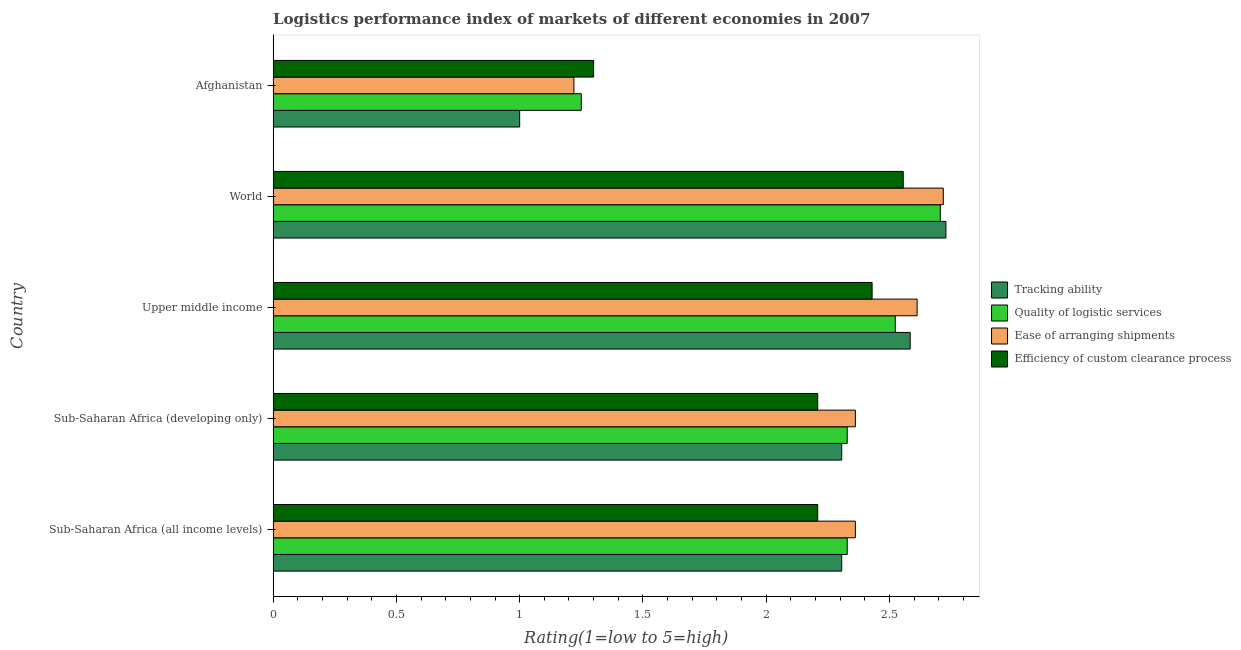How many groups of bars are there?
Provide a short and direct response. 5. Are the number of bars per tick equal to the number of legend labels?
Make the answer very short. Yes. How many bars are there on the 4th tick from the top?
Provide a succinct answer. 4. What is the label of the 4th group of bars from the top?
Offer a very short reply. Sub-Saharan Africa (developing only). In how many cases, is the number of bars for a given country not equal to the number of legend labels?
Give a very brief answer. 0. What is the lpi rating of efficiency of custom clearance process in Sub-Saharan Africa (developing only)?
Provide a short and direct response. 2.21. Across all countries, what is the maximum lpi rating of tracking ability?
Ensure brevity in your answer.  2.73. In which country was the lpi rating of tracking ability minimum?
Provide a short and direct response. Afghanistan. What is the total lpi rating of efficiency of custom clearance process in the graph?
Make the answer very short. 10.7. What is the difference between the lpi rating of quality of logistic services in Sub-Saharan Africa (all income levels) and that in Upper middle income?
Your answer should be compact. -0.2. What is the difference between the lpi rating of quality of logistic services in World and the lpi rating of ease of arranging shipments in Afghanistan?
Keep it short and to the point. 1.49. What is the average lpi rating of tracking ability per country?
Offer a very short reply. 2.19. What is the difference between the lpi rating of tracking ability and lpi rating of efficiency of custom clearance process in Sub-Saharan Africa (developing only)?
Offer a very short reply. 0.1. In how many countries, is the lpi rating of quality of logistic services greater than 0.2 ?
Your answer should be very brief. 5. What is the ratio of the lpi rating of ease of arranging shipments in Sub-Saharan Africa (all income levels) to that in World?
Make the answer very short. 0.87. Is the lpi rating of ease of arranging shipments in Sub-Saharan Africa (all income levels) less than that in World?
Your response must be concise. Yes. What is the difference between the highest and the second highest lpi rating of tracking ability?
Ensure brevity in your answer.  0.14. What is the difference between the highest and the lowest lpi rating of quality of logistic services?
Your answer should be very brief. 1.46. Is the sum of the lpi rating of efficiency of custom clearance process in Sub-Saharan Africa (all income levels) and Sub-Saharan Africa (developing only) greater than the maximum lpi rating of tracking ability across all countries?
Give a very brief answer. Yes. Is it the case that in every country, the sum of the lpi rating of efficiency of custom clearance process and lpi rating of tracking ability is greater than the sum of lpi rating of quality of logistic services and lpi rating of ease of arranging shipments?
Your answer should be very brief. No. What does the 2nd bar from the top in World represents?
Your answer should be compact. Ease of arranging shipments. What does the 3rd bar from the bottom in World represents?
Your answer should be very brief. Ease of arranging shipments. Are all the bars in the graph horizontal?
Your answer should be compact. Yes. Are the values on the major ticks of X-axis written in scientific E-notation?
Your answer should be very brief. No. Does the graph contain grids?
Ensure brevity in your answer.  No. Where does the legend appear in the graph?
Your answer should be compact. Center right. What is the title of the graph?
Keep it short and to the point. Logistics performance index of markets of different economies in 2007. What is the label or title of the X-axis?
Provide a short and direct response. Rating(1=low to 5=high). What is the Rating(1=low to 5=high) in Tracking ability in Sub-Saharan Africa (all income levels)?
Provide a short and direct response. 2.31. What is the Rating(1=low to 5=high) of Quality of logistic services in Sub-Saharan Africa (all income levels)?
Make the answer very short. 2.33. What is the Rating(1=low to 5=high) in Ease of arranging shipments in Sub-Saharan Africa (all income levels)?
Your answer should be compact. 2.36. What is the Rating(1=low to 5=high) of Efficiency of custom clearance process in Sub-Saharan Africa (all income levels)?
Make the answer very short. 2.21. What is the Rating(1=low to 5=high) of Tracking ability in Sub-Saharan Africa (developing only)?
Offer a terse response. 2.31. What is the Rating(1=low to 5=high) in Quality of logistic services in Sub-Saharan Africa (developing only)?
Offer a very short reply. 2.33. What is the Rating(1=low to 5=high) in Ease of arranging shipments in Sub-Saharan Africa (developing only)?
Give a very brief answer. 2.36. What is the Rating(1=low to 5=high) of Efficiency of custom clearance process in Sub-Saharan Africa (developing only)?
Provide a short and direct response. 2.21. What is the Rating(1=low to 5=high) of Tracking ability in Upper middle income?
Offer a terse response. 2.58. What is the Rating(1=low to 5=high) of Quality of logistic services in Upper middle income?
Offer a very short reply. 2.52. What is the Rating(1=low to 5=high) in Ease of arranging shipments in Upper middle income?
Offer a very short reply. 2.61. What is the Rating(1=low to 5=high) in Efficiency of custom clearance process in Upper middle income?
Your answer should be compact. 2.43. What is the Rating(1=low to 5=high) of Tracking ability in World?
Provide a succinct answer. 2.73. What is the Rating(1=low to 5=high) in Quality of logistic services in World?
Your answer should be very brief. 2.71. What is the Rating(1=low to 5=high) of Ease of arranging shipments in World?
Your answer should be compact. 2.72. What is the Rating(1=low to 5=high) in Efficiency of custom clearance process in World?
Offer a terse response. 2.56. What is the Rating(1=low to 5=high) in Ease of arranging shipments in Afghanistan?
Provide a succinct answer. 1.22. What is the Rating(1=low to 5=high) in Efficiency of custom clearance process in Afghanistan?
Ensure brevity in your answer.  1.3. Across all countries, what is the maximum Rating(1=low to 5=high) in Tracking ability?
Provide a short and direct response. 2.73. Across all countries, what is the maximum Rating(1=low to 5=high) of Quality of logistic services?
Your answer should be very brief. 2.71. Across all countries, what is the maximum Rating(1=low to 5=high) in Ease of arranging shipments?
Offer a terse response. 2.72. Across all countries, what is the maximum Rating(1=low to 5=high) in Efficiency of custom clearance process?
Ensure brevity in your answer.  2.56. Across all countries, what is the minimum Rating(1=low to 5=high) of Quality of logistic services?
Offer a terse response. 1.25. Across all countries, what is the minimum Rating(1=low to 5=high) in Ease of arranging shipments?
Offer a very short reply. 1.22. What is the total Rating(1=low to 5=high) in Tracking ability in the graph?
Give a very brief answer. 10.93. What is the total Rating(1=low to 5=high) of Quality of logistic services in the graph?
Your response must be concise. 11.14. What is the total Rating(1=low to 5=high) of Ease of arranging shipments in the graph?
Your answer should be very brief. 11.27. What is the total Rating(1=low to 5=high) in Efficiency of custom clearance process in the graph?
Provide a short and direct response. 10.7. What is the difference between the Rating(1=low to 5=high) in Quality of logistic services in Sub-Saharan Africa (all income levels) and that in Sub-Saharan Africa (developing only)?
Offer a terse response. 0. What is the difference between the Rating(1=low to 5=high) in Ease of arranging shipments in Sub-Saharan Africa (all income levels) and that in Sub-Saharan Africa (developing only)?
Your answer should be very brief. 0. What is the difference between the Rating(1=low to 5=high) of Efficiency of custom clearance process in Sub-Saharan Africa (all income levels) and that in Sub-Saharan Africa (developing only)?
Make the answer very short. 0. What is the difference between the Rating(1=low to 5=high) of Tracking ability in Sub-Saharan Africa (all income levels) and that in Upper middle income?
Your answer should be compact. -0.28. What is the difference between the Rating(1=low to 5=high) of Quality of logistic services in Sub-Saharan Africa (all income levels) and that in Upper middle income?
Your response must be concise. -0.2. What is the difference between the Rating(1=low to 5=high) of Ease of arranging shipments in Sub-Saharan Africa (all income levels) and that in Upper middle income?
Your answer should be very brief. -0.25. What is the difference between the Rating(1=low to 5=high) of Efficiency of custom clearance process in Sub-Saharan Africa (all income levels) and that in Upper middle income?
Provide a short and direct response. -0.22. What is the difference between the Rating(1=low to 5=high) of Tracking ability in Sub-Saharan Africa (all income levels) and that in World?
Your answer should be compact. -0.42. What is the difference between the Rating(1=low to 5=high) in Quality of logistic services in Sub-Saharan Africa (all income levels) and that in World?
Provide a succinct answer. -0.38. What is the difference between the Rating(1=low to 5=high) of Ease of arranging shipments in Sub-Saharan Africa (all income levels) and that in World?
Offer a very short reply. -0.36. What is the difference between the Rating(1=low to 5=high) of Efficiency of custom clearance process in Sub-Saharan Africa (all income levels) and that in World?
Your response must be concise. -0.35. What is the difference between the Rating(1=low to 5=high) of Tracking ability in Sub-Saharan Africa (all income levels) and that in Afghanistan?
Provide a succinct answer. 1.31. What is the difference between the Rating(1=low to 5=high) in Quality of logistic services in Sub-Saharan Africa (all income levels) and that in Afghanistan?
Provide a succinct answer. 1.08. What is the difference between the Rating(1=low to 5=high) of Ease of arranging shipments in Sub-Saharan Africa (all income levels) and that in Afghanistan?
Keep it short and to the point. 1.14. What is the difference between the Rating(1=low to 5=high) of Efficiency of custom clearance process in Sub-Saharan Africa (all income levels) and that in Afghanistan?
Offer a very short reply. 0.91. What is the difference between the Rating(1=low to 5=high) of Tracking ability in Sub-Saharan Africa (developing only) and that in Upper middle income?
Give a very brief answer. -0.28. What is the difference between the Rating(1=low to 5=high) in Quality of logistic services in Sub-Saharan Africa (developing only) and that in Upper middle income?
Make the answer very short. -0.2. What is the difference between the Rating(1=low to 5=high) of Ease of arranging shipments in Sub-Saharan Africa (developing only) and that in Upper middle income?
Your response must be concise. -0.25. What is the difference between the Rating(1=low to 5=high) in Efficiency of custom clearance process in Sub-Saharan Africa (developing only) and that in Upper middle income?
Make the answer very short. -0.22. What is the difference between the Rating(1=low to 5=high) of Tracking ability in Sub-Saharan Africa (developing only) and that in World?
Your answer should be compact. -0.42. What is the difference between the Rating(1=low to 5=high) in Quality of logistic services in Sub-Saharan Africa (developing only) and that in World?
Your response must be concise. -0.38. What is the difference between the Rating(1=low to 5=high) of Ease of arranging shipments in Sub-Saharan Africa (developing only) and that in World?
Offer a very short reply. -0.36. What is the difference between the Rating(1=low to 5=high) of Efficiency of custom clearance process in Sub-Saharan Africa (developing only) and that in World?
Your response must be concise. -0.35. What is the difference between the Rating(1=low to 5=high) of Tracking ability in Sub-Saharan Africa (developing only) and that in Afghanistan?
Your response must be concise. 1.31. What is the difference between the Rating(1=low to 5=high) of Quality of logistic services in Sub-Saharan Africa (developing only) and that in Afghanistan?
Your response must be concise. 1.08. What is the difference between the Rating(1=low to 5=high) of Ease of arranging shipments in Sub-Saharan Africa (developing only) and that in Afghanistan?
Your answer should be very brief. 1.14. What is the difference between the Rating(1=low to 5=high) in Efficiency of custom clearance process in Sub-Saharan Africa (developing only) and that in Afghanistan?
Keep it short and to the point. 0.91. What is the difference between the Rating(1=low to 5=high) in Tracking ability in Upper middle income and that in World?
Provide a succinct answer. -0.14. What is the difference between the Rating(1=low to 5=high) of Quality of logistic services in Upper middle income and that in World?
Your answer should be compact. -0.18. What is the difference between the Rating(1=low to 5=high) of Ease of arranging shipments in Upper middle income and that in World?
Your response must be concise. -0.11. What is the difference between the Rating(1=low to 5=high) of Efficiency of custom clearance process in Upper middle income and that in World?
Offer a very short reply. -0.13. What is the difference between the Rating(1=low to 5=high) of Tracking ability in Upper middle income and that in Afghanistan?
Provide a succinct answer. 1.58. What is the difference between the Rating(1=low to 5=high) of Quality of logistic services in Upper middle income and that in Afghanistan?
Your answer should be very brief. 1.27. What is the difference between the Rating(1=low to 5=high) of Ease of arranging shipments in Upper middle income and that in Afghanistan?
Your answer should be compact. 1.39. What is the difference between the Rating(1=low to 5=high) of Efficiency of custom clearance process in Upper middle income and that in Afghanistan?
Provide a short and direct response. 1.13. What is the difference between the Rating(1=low to 5=high) of Tracking ability in World and that in Afghanistan?
Provide a short and direct response. 1.73. What is the difference between the Rating(1=low to 5=high) of Quality of logistic services in World and that in Afghanistan?
Your answer should be compact. 1.46. What is the difference between the Rating(1=low to 5=high) in Ease of arranging shipments in World and that in Afghanistan?
Keep it short and to the point. 1.5. What is the difference between the Rating(1=low to 5=high) of Efficiency of custom clearance process in World and that in Afghanistan?
Give a very brief answer. 1.26. What is the difference between the Rating(1=low to 5=high) of Tracking ability in Sub-Saharan Africa (all income levels) and the Rating(1=low to 5=high) of Quality of logistic services in Sub-Saharan Africa (developing only)?
Provide a succinct answer. -0.02. What is the difference between the Rating(1=low to 5=high) in Tracking ability in Sub-Saharan Africa (all income levels) and the Rating(1=low to 5=high) in Ease of arranging shipments in Sub-Saharan Africa (developing only)?
Ensure brevity in your answer.  -0.06. What is the difference between the Rating(1=low to 5=high) of Tracking ability in Sub-Saharan Africa (all income levels) and the Rating(1=low to 5=high) of Efficiency of custom clearance process in Sub-Saharan Africa (developing only)?
Ensure brevity in your answer.  0.1. What is the difference between the Rating(1=low to 5=high) in Quality of logistic services in Sub-Saharan Africa (all income levels) and the Rating(1=low to 5=high) in Ease of arranging shipments in Sub-Saharan Africa (developing only)?
Your response must be concise. -0.03. What is the difference between the Rating(1=low to 5=high) in Quality of logistic services in Sub-Saharan Africa (all income levels) and the Rating(1=low to 5=high) in Efficiency of custom clearance process in Sub-Saharan Africa (developing only)?
Your answer should be compact. 0.12. What is the difference between the Rating(1=low to 5=high) of Ease of arranging shipments in Sub-Saharan Africa (all income levels) and the Rating(1=low to 5=high) of Efficiency of custom clearance process in Sub-Saharan Africa (developing only)?
Provide a short and direct response. 0.15. What is the difference between the Rating(1=low to 5=high) of Tracking ability in Sub-Saharan Africa (all income levels) and the Rating(1=low to 5=high) of Quality of logistic services in Upper middle income?
Your answer should be very brief. -0.22. What is the difference between the Rating(1=low to 5=high) of Tracking ability in Sub-Saharan Africa (all income levels) and the Rating(1=low to 5=high) of Ease of arranging shipments in Upper middle income?
Offer a terse response. -0.31. What is the difference between the Rating(1=low to 5=high) in Tracking ability in Sub-Saharan Africa (all income levels) and the Rating(1=low to 5=high) in Efficiency of custom clearance process in Upper middle income?
Offer a very short reply. -0.12. What is the difference between the Rating(1=low to 5=high) of Quality of logistic services in Sub-Saharan Africa (all income levels) and the Rating(1=low to 5=high) of Ease of arranging shipments in Upper middle income?
Your response must be concise. -0.28. What is the difference between the Rating(1=low to 5=high) in Quality of logistic services in Sub-Saharan Africa (all income levels) and the Rating(1=low to 5=high) in Efficiency of custom clearance process in Upper middle income?
Your answer should be very brief. -0.1. What is the difference between the Rating(1=low to 5=high) in Ease of arranging shipments in Sub-Saharan Africa (all income levels) and the Rating(1=low to 5=high) in Efficiency of custom clearance process in Upper middle income?
Your answer should be very brief. -0.07. What is the difference between the Rating(1=low to 5=high) of Tracking ability in Sub-Saharan Africa (all income levels) and the Rating(1=low to 5=high) of Quality of logistic services in World?
Your answer should be compact. -0.4. What is the difference between the Rating(1=low to 5=high) in Tracking ability in Sub-Saharan Africa (all income levels) and the Rating(1=low to 5=high) in Ease of arranging shipments in World?
Give a very brief answer. -0.41. What is the difference between the Rating(1=low to 5=high) of Tracking ability in Sub-Saharan Africa (all income levels) and the Rating(1=low to 5=high) of Efficiency of custom clearance process in World?
Provide a short and direct response. -0.25. What is the difference between the Rating(1=low to 5=high) of Quality of logistic services in Sub-Saharan Africa (all income levels) and the Rating(1=low to 5=high) of Ease of arranging shipments in World?
Provide a short and direct response. -0.39. What is the difference between the Rating(1=low to 5=high) of Quality of logistic services in Sub-Saharan Africa (all income levels) and the Rating(1=low to 5=high) of Efficiency of custom clearance process in World?
Ensure brevity in your answer.  -0.23. What is the difference between the Rating(1=low to 5=high) of Ease of arranging shipments in Sub-Saharan Africa (all income levels) and the Rating(1=low to 5=high) of Efficiency of custom clearance process in World?
Provide a succinct answer. -0.19. What is the difference between the Rating(1=low to 5=high) in Tracking ability in Sub-Saharan Africa (all income levels) and the Rating(1=low to 5=high) in Quality of logistic services in Afghanistan?
Offer a terse response. 1.06. What is the difference between the Rating(1=low to 5=high) in Tracking ability in Sub-Saharan Africa (all income levels) and the Rating(1=low to 5=high) in Ease of arranging shipments in Afghanistan?
Keep it short and to the point. 1.09. What is the difference between the Rating(1=low to 5=high) of Tracking ability in Sub-Saharan Africa (all income levels) and the Rating(1=low to 5=high) of Efficiency of custom clearance process in Afghanistan?
Your answer should be very brief. 1.01. What is the difference between the Rating(1=low to 5=high) of Quality of logistic services in Sub-Saharan Africa (all income levels) and the Rating(1=low to 5=high) of Ease of arranging shipments in Afghanistan?
Your answer should be very brief. 1.11. What is the difference between the Rating(1=low to 5=high) of Quality of logistic services in Sub-Saharan Africa (all income levels) and the Rating(1=low to 5=high) of Efficiency of custom clearance process in Afghanistan?
Make the answer very short. 1.03. What is the difference between the Rating(1=low to 5=high) of Ease of arranging shipments in Sub-Saharan Africa (all income levels) and the Rating(1=low to 5=high) of Efficiency of custom clearance process in Afghanistan?
Your response must be concise. 1.06. What is the difference between the Rating(1=low to 5=high) in Tracking ability in Sub-Saharan Africa (developing only) and the Rating(1=low to 5=high) in Quality of logistic services in Upper middle income?
Give a very brief answer. -0.22. What is the difference between the Rating(1=low to 5=high) of Tracking ability in Sub-Saharan Africa (developing only) and the Rating(1=low to 5=high) of Ease of arranging shipments in Upper middle income?
Your answer should be compact. -0.31. What is the difference between the Rating(1=low to 5=high) of Tracking ability in Sub-Saharan Africa (developing only) and the Rating(1=low to 5=high) of Efficiency of custom clearance process in Upper middle income?
Your answer should be compact. -0.12. What is the difference between the Rating(1=low to 5=high) of Quality of logistic services in Sub-Saharan Africa (developing only) and the Rating(1=low to 5=high) of Ease of arranging shipments in Upper middle income?
Give a very brief answer. -0.28. What is the difference between the Rating(1=low to 5=high) of Quality of logistic services in Sub-Saharan Africa (developing only) and the Rating(1=low to 5=high) of Efficiency of custom clearance process in Upper middle income?
Give a very brief answer. -0.1. What is the difference between the Rating(1=low to 5=high) of Ease of arranging shipments in Sub-Saharan Africa (developing only) and the Rating(1=low to 5=high) of Efficiency of custom clearance process in Upper middle income?
Provide a short and direct response. -0.07. What is the difference between the Rating(1=low to 5=high) of Tracking ability in Sub-Saharan Africa (developing only) and the Rating(1=low to 5=high) of Quality of logistic services in World?
Offer a terse response. -0.4. What is the difference between the Rating(1=low to 5=high) in Tracking ability in Sub-Saharan Africa (developing only) and the Rating(1=low to 5=high) in Ease of arranging shipments in World?
Provide a succinct answer. -0.41. What is the difference between the Rating(1=low to 5=high) of Tracking ability in Sub-Saharan Africa (developing only) and the Rating(1=low to 5=high) of Efficiency of custom clearance process in World?
Give a very brief answer. -0.25. What is the difference between the Rating(1=low to 5=high) of Quality of logistic services in Sub-Saharan Africa (developing only) and the Rating(1=low to 5=high) of Ease of arranging shipments in World?
Your response must be concise. -0.39. What is the difference between the Rating(1=low to 5=high) of Quality of logistic services in Sub-Saharan Africa (developing only) and the Rating(1=low to 5=high) of Efficiency of custom clearance process in World?
Your response must be concise. -0.23. What is the difference between the Rating(1=low to 5=high) in Ease of arranging shipments in Sub-Saharan Africa (developing only) and the Rating(1=low to 5=high) in Efficiency of custom clearance process in World?
Make the answer very short. -0.19. What is the difference between the Rating(1=low to 5=high) in Tracking ability in Sub-Saharan Africa (developing only) and the Rating(1=low to 5=high) in Quality of logistic services in Afghanistan?
Your response must be concise. 1.06. What is the difference between the Rating(1=low to 5=high) of Tracking ability in Sub-Saharan Africa (developing only) and the Rating(1=low to 5=high) of Ease of arranging shipments in Afghanistan?
Provide a short and direct response. 1.09. What is the difference between the Rating(1=low to 5=high) in Tracking ability in Sub-Saharan Africa (developing only) and the Rating(1=low to 5=high) in Efficiency of custom clearance process in Afghanistan?
Give a very brief answer. 1.01. What is the difference between the Rating(1=low to 5=high) of Quality of logistic services in Sub-Saharan Africa (developing only) and the Rating(1=low to 5=high) of Ease of arranging shipments in Afghanistan?
Your response must be concise. 1.11. What is the difference between the Rating(1=low to 5=high) in Quality of logistic services in Sub-Saharan Africa (developing only) and the Rating(1=low to 5=high) in Efficiency of custom clearance process in Afghanistan?
Ensure brevity in your answer.  1.03. What is the difference between the Rating(1=low to 5=high) of Ease of arranging shipments in Sub-Saharan Africa (developing only) and the Rating(1=low to 5=high) of Efficiency of custom clearance process in Afghanistan?
Offer a terse response. 1.06. What is the difference between the Rating(1=low to 5=high) in Tracking ability in Upper middle income and the Rating(1=low to 5=high) in Quality of logistic services in World?
Offer a terse response. -0.12. What is the difference between the Rating(1=low to 5=high) in Tracking ability in Upper middle income and the Rating(1=low to 5=high) in Ease of arranging shipments in World?
Offer a very short reply. -0.13. What is the difference between the Rating(1=low to 5=high) in Tracking ability in Upper middle income and the Rating(1=low to 5=high) in Efficiency of custom clearance process in World?
Your response must be concise. 0.03. What is the difference between the Rating(1=low to 5=high) of Quality of logistic services in Upper middle income and the Rating(1=low to 5=high) of Ease of arranging shipments in World?
Your answer should be compact. -0.19. What is the difference between the Rating(1=low to 5=high) in Quality of logistic services in Upper middle income and the Rating(1=low to 5=high) in Efficiency of custom clearance process in World?
Offer a terse response. -0.03. What is the difference between the Rating(1=low to 5=high) of Ease of arranging shipments in Upper middle income and the Rating(1=low to 5=high) of Efficiency of custom clearance process in World?
Offer a very short reply. 0.06. What is the difference between the Rating(1=low to 5=high) in Tracking ability in Upper middle income and the Rating(1=low to 5=high) in Quality of logistic services in Afghanistan?
Provide a short and direct response. 1.33. What is the difference between the Rating(1=low to 5=high) of Tracking ability in Upper middle income and the Rating(1=low to 5=high) of Ease of arranging shipments in Afghanistan?
Offer a terse response. 1.36. What is the difference between the Rating(1=low to 5=high) of Tracking ability in Upper middle income and the Rating(1=low to 5=high) of Efficiency of custom clearance process in Afghanistan?
Give a very brief answer. 1.28. What is the difference between the Rating(1=low to 5=high) in Quality of logistic services in Upper middle income and the Rating(1=low to 5=high) in Ease of arranging shipments in Afghanistan?
Give a very brief answer. 1.3. What is the difference between the Rating(1=low to 5=high) of Quality of logistic services in Upper middle income and the Rating(1=low to 5=high) of Efficiency of custom clearance process in Afghanistan?
Offer a terse response. 1.22. What is the difference between the Rating(1=low to 5=high) of Ease of arranging shipments in Upper middle income and the Rating(1=low to 5=high) of Efficiency of custom clearance process in Afghanistan?
Your answer should be very brief. 1.31. What is the difference between the Rating(1=low to 5=high) in Tracking ability in World and the Rating(1=low to 5=high) in Quality of logistic services in Afghanistan?
Your answer should be very brief. 1.48. What is the difference between the Rating(1=low to 5=high) of Tracking ability in World and the Rating(1=low to 5=high) of Ease of arranging shipments in Afghanistan?
Your answer should be compact. 1.51. What is the difference between the Rating(1=low to 5=high) in Tracking ability in World and the Rating(1=low to 5=high) in Efficiency of custom clearance process in Afghanistan?
Your response must be concise. 1.43. What is the difference between the Rating(1=low to 5=high) in Quality of logistic services in World and the Rating(1=low to 5=high) in Ease of arranging shipments in Afghanistan?
Offer a very short reply. 1.49. What is the difference between the Rating(1=low to 5=high) of Quality of logistic services in World and the Rating(1=low to 5=high) of Efficiency of custom clearance process in Afghanistan?
Provide a succinct answer. 1.41. What is the difference between the Rating(1=low to 5=high) in Ease of arranging shipments in World and the Rating(1=low to 5=high) in Efficiency of custom clearance process in Afghanistan?
Offer a very short reply. 1.42. What is the average Rating(1=low to 5=high) in Tracking ability per country?
Give a very brief answer. 2.19. What is the average Rating(1=low to 5=high) of Quality of logistic services per country?
Provide a short and direct response. 2.23. What is the average Rating(1=low to 5=high) in Ease of arranging shipments per country?
Your response must be concise. 2.25. What is the average Rating(1=low to 5=high) of Efficiency of custom clearance process per country?
Give a very brief answer. 2.14. What is the difference between the Rating(1=low to 5=high) in Tracking ability and Rating(1=low to 5=high) in Quality of logistic services in Sub-Saharan Africa (all income levels)?
Offer a very short reply. -0.02. What is the difference between the Rating(1=low to 5=high) of Tracking ability and Rating(1=low to 5=high) of Ease of arranging shipments in Sub-Saharan Africa (all income levels)?
Provide a short and direct response. -0.06. What is the difference between the Rating(1=low to 5=high) in Tracking ability and Rating(1=low to 5=high) in Efficiency of custom clearance process in Sub-Saharan Africa (all income levels)?
Provide a succinct answer. 0.1. What is the difference between the Rating(1=low to 5=high) in Quality of logistic services and Rating(1=low to 5=high) in Ease of arranging shipments in Sub-Saharan Africa (all income levels)?
Make the answer very short. -0.03. What is the difference between the Rating(1=low to 5=high) in Quality of logistic services and Rating(1=low to 5=high) in Efficiency of custom clearance process in Sub-Saharan Africa (all income levels)?
Provide a succinct answer. 0.12. What is the difference between the Rating(1=low to 5=high) of Ease of arranging shipments and Rating(1=low to 5=high) of Efficiency of custom clearance process in Sub-Saharan Africa (all income levels)?
Offer a very short reply. 0.15. What is the difference between the Rating(1=low to 5=high) of Tracking ability and Rating(1=low to 5=high) of Quality of logistic services in Sub-Saharan Africa (developing only)?
Provide a succinct answer. -0.02. What is the difference between the Rating(1=low to 5=high) of Tracking ability and Rating(1=low to 5=high) of Ease of arranging shipments in Sub-Saharan Africa (developing only)?
Offer a very short reply. -0.06. What is the difference between the Rating(1=low to 5=high) of Tracking ability and Rating(1=low to 5=high) of Efficiency of custom clearance process in Sub-Saharan Africa (developing only)?
Keep it short and to the point. 0.1. What is the difference between the Rating(1=low to 5=high) in Quality of logistic services and Rating(1=low to 5=high) in Ease of arranging shipments in Sub-Saharan Africa (developing only)?
Make the answer very short. -0.03. What is the difference between the Rating(1=low to 5=high) of Quality of logistic services and Rating(1=low to 5=high) of Efficiency of custom clearance process in Sub-Saharan Africa (developing only)?
Offer a very short reply. 0.12. What is the difference between the Rating(1=low to 5=high) of Ease of arranging shipments and Rating(1=low to 5=high) of Efficiency of custom clearance process in Sub-Saharan Africa (developing only)?
Your response must be concise. 0.15. What is the difference between the Rating(1=low to 5=high) in Tracking ability and Rating(1=low to 5=high) in Quality of logistic services in Upper middle income?
Provide a short and direct response. 0.06. What is the difference between the Rating(1=low to 5=high) in Tracking ability and Rating(1=low to 5=high) in Ease of arranging shipments in Upper middle income?
Ensure brevity in your answer.  -0.03. What is the difference between the Rating(1=low to 5=high) of Tracking ability and Rating(1=low to 5=high) of Efficiency of custom clearance process in Upper middle income?
Offer a terse response. 0.15. What is the difference between the Rating(1=low to 5=high) of Quality of logistic services and Rating(1=low to 5=high) of Ease of arranging shipments in Upper middle income?
Offer a terse response. -0.09. What is the difference between the Rating(1=low to 5=high) in Quality of logistic services and Rating(1=low to 5=high) in Efficiency of custom clearance process in Upper middle income?
Ensure brevity in your answer.  0.09. What is the difference between the Rating(1=low to 5=high) of Ease of arranging shipments and Rating(1=low to 5=high) of Efficiency of custom clearance process in Upper middle income?
Give a very brief answer. 0.18. What is the difference between the Rating(1=low to 5=high) of Tracking ability and Rating(1=low to 5=high) of Quality of logistic services in World?
Offer a very short reply. 0.02. What is the difference between the Rating(1=low to 5=high) of Tracking ability and Rating(1=low to 5=high) of Ease of arranging shipments in World?
Make the answer very short. 0.01. What is the difference between the Rating(1=low to 5=high) of Tracking ability and Rating(1=low to 5=high) of Efficiency of custom clearance process in World?
Ensure brevity in your answer.  0.17. What is the difference between the Rating(1=low to 5=high) of Quality of logistic services and Rating(1=low to 5=high) of Ease of arranging shipments in World?
Provide a succinct answer. -0.01. What is the difference between the Rating(1=low to 5=high) of Quality of logistic services and Rating(1=low to 5=high) of Efficiency of custom clearance process in World?
Your answer should be compact. 0.15. What is the difference between the Rating(1=low to 5=high) in Ease of arranging shipments and Rating(1=low to 5=high) in Efficiency of custom clearance process in World?
Your answer should be compact. 0.16. What is the difference between the Rating(1=low to 5=high) of Tracking ability and Rating(1=low to 5=high) of Quality of logistic services in Afghanistan?
Offer a very short reply. -0.25. What is the difference between the Rating(1=low to 5=high) of Tracking ability and Rating(1=low to 5=high) of Ease of arranging shipments in Afghanistan?
Provide a short and direct response. -0.22. What is the difference between the Rating(1=low to 5=high) in Quality of logistic services and Rating(1=low to 5=high) in Efficiency of custom clearance process in Afghanistan?
Provide a succinct answer. -0.05. What is the difference between the Rating(1=low to 5=high) of Ease of arranging shipments and Rating(1=low to 5=high) of Efficiency of custom clearance process in Afghanistan?
Your answer should be very brief. -0.08. What is the ratio of the Rating(1=low to 5=high) of Efficiency of custom clearance process in Sub-Saharan Africa (all income levels) to that in Sub-Saharan Africa (developing only)?
Ensure brevity in your answer.  1. What is the ratio of the Rating(1=low to 5=high) in Tracking ability in Sub-Saharan Africa (all income levels) to that in Upper middle income?
Make the answer very short. 0.89. What is the ratio of the Rating(1=low to 5=high) in Quality of logistic services in Sub-Saharan Africa (all income levels) to that in Upper middle income?
Ensure brevity in your answer.  0.92. What is the ratio of the Rating(1=low to 5=high) of Ease of arranging shipments in Sub-Saharan Africa (all income levels) to that in Upper middle income?
Keep it short and to the point. 0.9. What is the ratio of the Rating(1=low to 5=high) in Efficiency of custom clearance process in Sub-Saharan Africa (all income levels) to that in Upper middle income?
Offer a terse response. 0.91. What is the ratio of the Rating(1=low to 5=high) of Tracking ability in Sub-Saharan Africa (all income levels) to that in World?
Ensure brevity in your answer.  0.85. What is the ratio of the Rating(1=low to 5=high) of Quality of logistic services in Sub-Saharan Africa (all income levels) to that in World?
Offer a terse response. 0.86. What is the ratio of the Rating(1=low to 5=high) of Ease of arranging shipments in Sub-Saharan Africa (all income levels) to that in World?
Provide a succinct answer. 0.87. What is the ratio of the Rating(1=low to 5=high) of Efficiency of custom clearance process in Sub-Saharan Africa (all income levels) to that in World?
Your answer should be compact. 0.86. What is the ratio of the Rating(1=low to 5=high) of Tracking ability in Sub-Saharan Africa (all income levels) to that in Afghanistan?
Your answer should be very brief. 2.31. What is the ratio of the Rating(1=low to 5=high) of Quality of logistic services in Sub-Saharan Africa (all income levels) to that in Afghanistan?
Make the answer very short. 1.86. What is the ratio of the Rating(1=low to 5=high) in Ease of arranging shipments in Sub-Saharan Africa (all income levels) to that in Afghanistan?
Ensure brevity in your answer.  1.94. What is the ratio of the Rating(1=low to 5=high) of Efficiency of custom clearance process in Sub-Saharan Africa (all income levels) to that in Afghanistan?
Your answer should be very brief. 1.7. What is the ratio of the Rating(1=low to 5=high) in Tracking ability in Sub-Saharan Africa (developing only) to that in Upper middle income?
Your response must be concise. 0.89. What is the ratio of the Rating(1=low to 5=high) of Quality of logistic services in Sub-Saharan Africa (developing only) to that in Upper middle income?
Provide a succinct answer. 0.92. What is the ratio of the Rating(1=low to 5=high) in Ease of arranging shipments in Sub-Saharan Africa (developing only) to that in Upper middle income?
Offer a very short reply. 0.9. What is the ratio of the Rating(1=low to 5=high) of Efficiency of custom clearance process in Sub-Saharan Africa (developing only) to that in Upper middle income?
Keep it short and to the point. 0.91. What is the ratio of the Rating(1=low to 5=high) in Tracking ability in Sub-Saharan Africa (developing only) to that in World?
Make the answer very short. 0.85. What is the ratio of the Rating(1=low to 5=high) in Quality of logistic services in Sub-Saharan Africa (developing only) to that in World?
Provide a short and direct response. 0.86. What is the ratio of the Rating(1=low to 5=high) in Ease of arranging shipments in Sub-Saharan Africa (developing only) to that in World?
Provide a succinct answer. 0.87. What is the ratio of the Rating(1=low to 5=high) in Efficiency of custom clearance process in Sub-Saharan Africa (developing only) to that in World?
Your answer should be very brief. 0.86. What is the ratio of the Rating(1=low to 5=high) in Tracking ability in Sub-Saharan Africa (developing only) to that in Afghanistan?
Offer a terse response. 2.31. What is the ratio of the Rating(1=low to 5=high) of Quality of logistic services in Sub-Saharan Africa (developing only) to that in Afghanistan?
Provide a succinct answer. 1.86. What is the ratio of the Rating(1=low to 5=high) in Ease of arranging shipments in Sub-Saharan Africa (developing only) to that in Afghanistan?
Your response must be concise. 1.94. What is the ratio of the Rating(1=low to 5=high) of Efficiency of custom clearance process in Sub-Saharan Africa (developing only) to that in Afghanistan?
Provide a succinct answer. 1.7. What is the ratio of the Rating(1=low to 5=high) in Tracking ability in Upper middle income to that in World?
Ensure brevity in your answer.  0.95. What is the ratio of the Rating(1=low to 5=high) of Quality of logistic services in Upper middle income to that in World?
Your answer should be very brief. 0.93. What is the ratio of the Rating(1=low to 5=high) in Efficiency of custom clearance process in Upper middle income to that in World?
Give a very brief answer. 0.95. What is the ratio of the Rating(1=low to 5=high) of Tracking ability in Upper middle income to that in Afghanistan?
Make the answer very short. 2.58. What is the ratio of the Rating(1=low to 5=high) in Quality of logistic services in Upper middle income to that in Afghanistan?
Your answer should be compact. 2.02. What is the ratio of the Rating(1=low to 5=high) in Ease of arranging shipments in Upper middle income to that in Afghanistan?
Make the answer very short. 2.14. What is the ratio of the Rating(1=low to 5=high) in Efficiency of custom clearance process in Upper middle income to that in Afghanistan?
Your response must be concise. 1.87. What is the ratio of the Rating(1=low to 5=high) in Tracking ability in World to that in Afghanistan?
Your response must be concise. 2.73. What is the ratio of the Rating(1=low to 5=high) in Quality of logistic services in World to that in Afghanistan?
Ensure brevity in your answer.  2.17. What is the ratio of the Rating(1=low to 5=high) in Ease of arranging shipments in World to that in Afghanistan?
Ensure brevity in your answer.  2.23. What is the ratio of the Rating(1=low to 5=high) in Efficiency of custom clearance process in World to that in Afghanistan?
Your answer should be compact. 1.97. What is the difference between the highest and the second highest Rating(1=low to 5=high) of Tracking ability?
Your answer should be compact. 0.14. What is the difference between the highest and the second highest Rating(1=low to 5=high) in Quality of logistic services?
Your response must be concise. 0.18. What is the difference between the highest and the second highest Rating(1=low to 5=high) of Ease of arranging shipments?
Offer a terse response. 0.11. What is the difference between the highest and the second highest Rating(1=low to 5=high) of Efficiency of custom clearance process?
Offer a very short reply. 0.13. What is the difference between the highest and the lowest Rating(1=low to 5=high) of Tracking ability?
Your answer should be compact. 1.73. What is the difference between the highest and the lowest Rating(1=low to 5=high) in Quality of logistic services?
Give a very brief answer. 1.46. What is the difference between the highest and the lowest Rating(1=low to 5=high) of Ease of arranging shipments?
Keep it short and to the point. 1.5. What is the difference between the highest and the lowest Rating(1=low to 5=high) in Efficiency of custom clearance process?
Give a very brief answer. 1.26. 